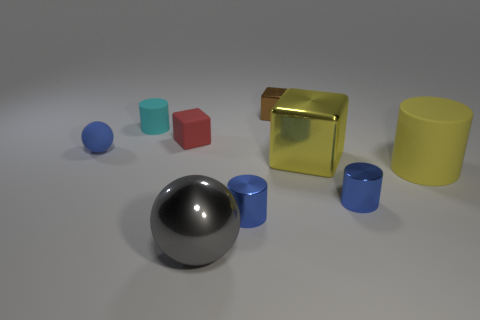Is the size of the yellow cylinder the same as the brown block?
Keep it short and to the point. No. How many balls are either small blue things or tiny things?
Provide a short and direct response. 1. How many tiny blocks are both on the left side of the big gray shiny object and behind the cyan cylinder?
Give a very brief answer. 0. There is a gray ball; is its size the same as the cylinder behind the matte block?
Ensure brevity in your answer.  No. There is a big yellow thing that is behind the rubber cylinder to the right of the yellow metal object; is there a metallic cube that is right of it?
Offer a very short reply. No. What is the material of the sphere that is right of the tiny rubber sphere that is on the left side of the large gray metallic object?
Provide a succinct answer. Metal. What is the tiny thing that is to the right of the big gray metallic thing and behind the red matte object made of?
Your answer should be compact. Metal. Are there any big gray objects of the same shape as the large yellow shiny thing?
Offer a very short reply. No. There is a blue thing that is on the left side of the shiny ball; is there a brown metal cube that is in front of it?
Offer a very short reply. No. How many small cylinders are the same material as the big yellow block?
Provide a short and direct response. 2. 